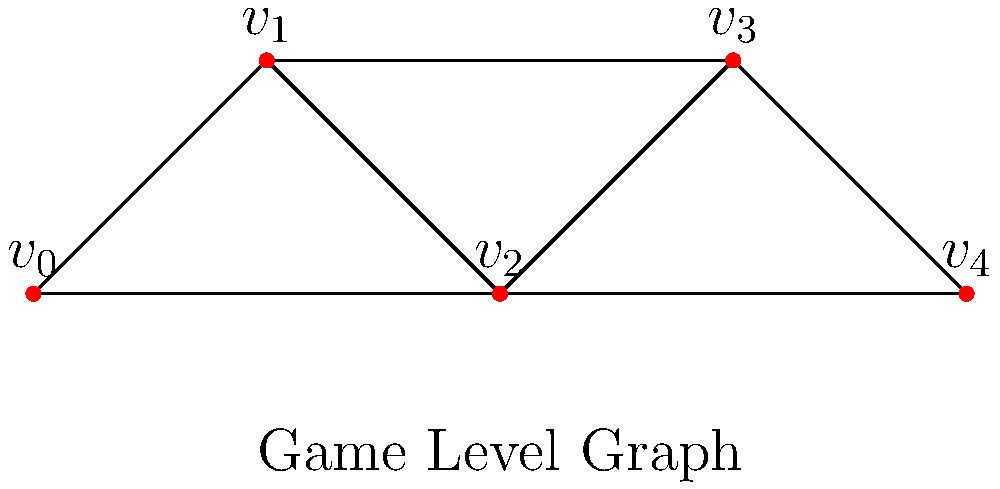In the context of an XNA/MonoGame indie game level design, consider the graph representation above. What is the vertex connectivity of this game level graph? To find the vertex connectivity of the graph, we need to follow these steps:

1. Understand vertex connectivity: It's the minimum number of vertices that need to be removed to disconnect the graph.

2. Analyze the graph structure:
   - The graph has 5 vertices: $v_0$, $v_1$, $v_2$, $v_3$, and $v_4$.
   - There are multiple paths between most pairs of vertices.

3. Identify critical vertices:
   - Removing $v_2$ would disconnect the graph into two components: {$v_0$, $v_1$} and {$v_3$, $v_4$}.
   - No single vertex other than $v_2$ can disconnect the graph when removed.

4. Check if removing any single vertex other than $v_2$ disconnects the graph:
   - Removing $v_0$, $v_1$, $v_3$, or $v_4$ leaves the graph connected.

5. Conclude:
   - Since removing only one vertex ($v_2$) can disconnect the graph, and no fewer vertices can do so, the vertex connectivity is 1.

In game design terms, this means that the level has a single critical point ($v_2$) that connects different areas of the level. This could represent a crucial room or passage that the player must go through to progress in the game.
Answer: 1 